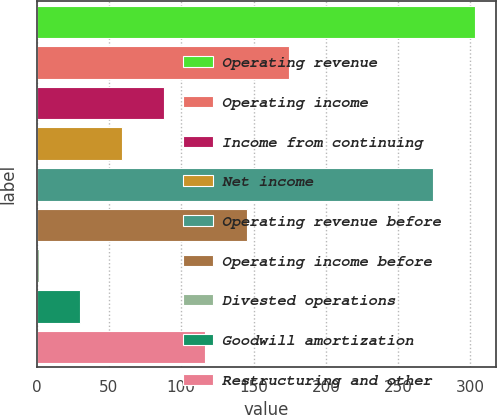Convert chart to OTSL. <chart><loc_0><loc_0><loc_500><loc_500><bar_chart><fcel>Operating revenue<fcel>Operating income<fcel>Income from continuing<fcel>Net income<fcel>Operating revenue before<fcel>Operating income before<fcel>Divested operations<fcel>Goodwill amortization<fcel>Restructuring and other<nl><fcel>302.83<fcel>174.38<fcel>87.89<fcel>59.06<fcel>274<fcel>145.55<fcel>1.4<fcel>30.23<fcel>116.72<nl></chart> 